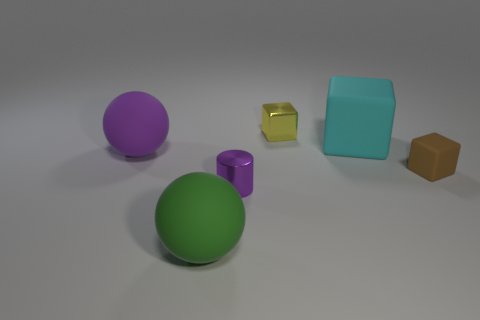Add 2 small cubes. How many objects exist? 8 Subtract all rubber cubes. How many cubes are left? 1 Subtract 1 balls. How many balls are left? 1 Subtract all brown cylinders. How many cyan blocks are left? 1 Subtract all large red rubber objects. Subtract all matte things. How many objects are left? 2 Add 5 small yellow objects. How many small yellow objects are left? 6 Add 2 large yellow rubber cylinders. How many large yellow rubber cylinders exist? 2 Subtract all brown cubes. How many cubes are left? 2 Subtract 0 purple cubes. How many objects are left? 6 Subtract all spheres. How many objects are left? 4 